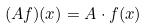Convert formula to latex. <formula><loc_0><loc_0><loc_500><loc_500>( A f ) ( x ) = A \cdot f ( x )</formula> 